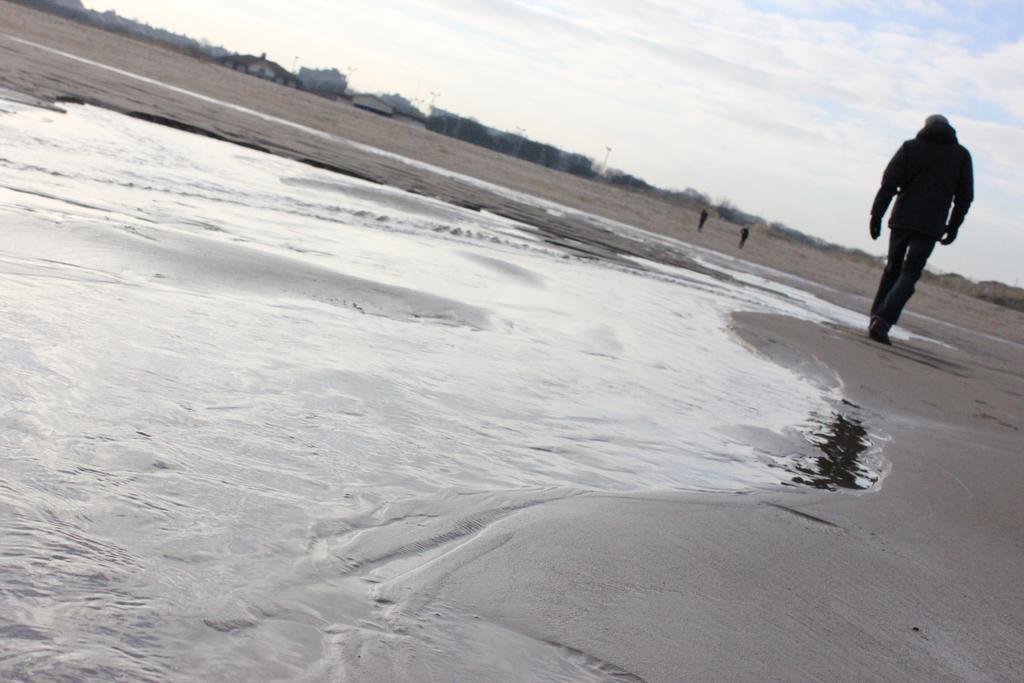Please provide a concise description of this image. This image is taken in the beach. In this image we can see a person walking. In the background we can see some houses and also two persons. Sky is also visible with clouds. 